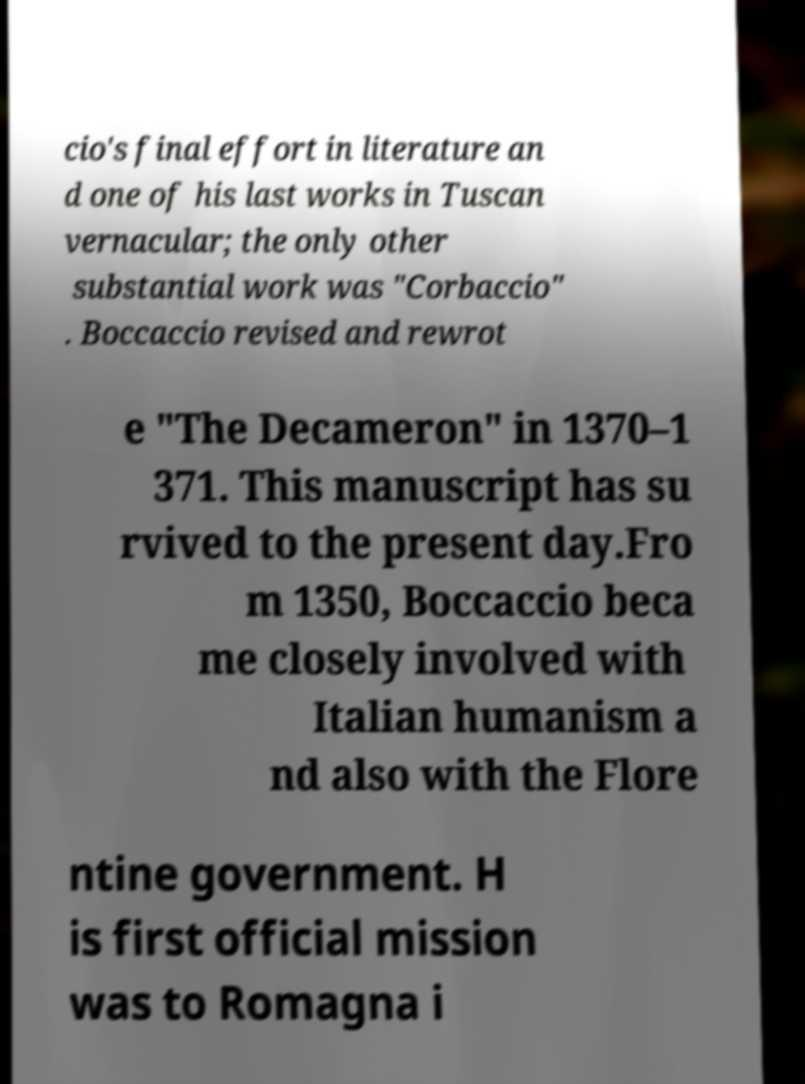I need the written content from this picture converted into text. Can you do that? cio's final effort in literature an d one of his last works in Tuscan vernacular; the only other substantial work was "Corbaccio" . Boccaccio revised and rewrot e "The Decameron" in 1370–1 371. This manuscript has su rvived to the present day.Fro m 1350, Boccaccio beca me closely involved with Italian humanism a nd also with the Flore ntine government. H is first official mission was to Romagna i 